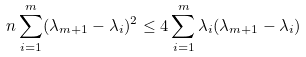Convert formula to latex. <formula><loc_0><loc_0><loc_500><loc_500>n \sum ^ { m } _ { i = 1 } ( \lambda _ { m + 1 } - \lambda _ { i } ) ^ { 2 } \leq 4 \sum ^ { m } _ { i = 1 } \lambda _ { i } ( \lambda _ { m + 1 } - \lambda _ { i } )</formula> 